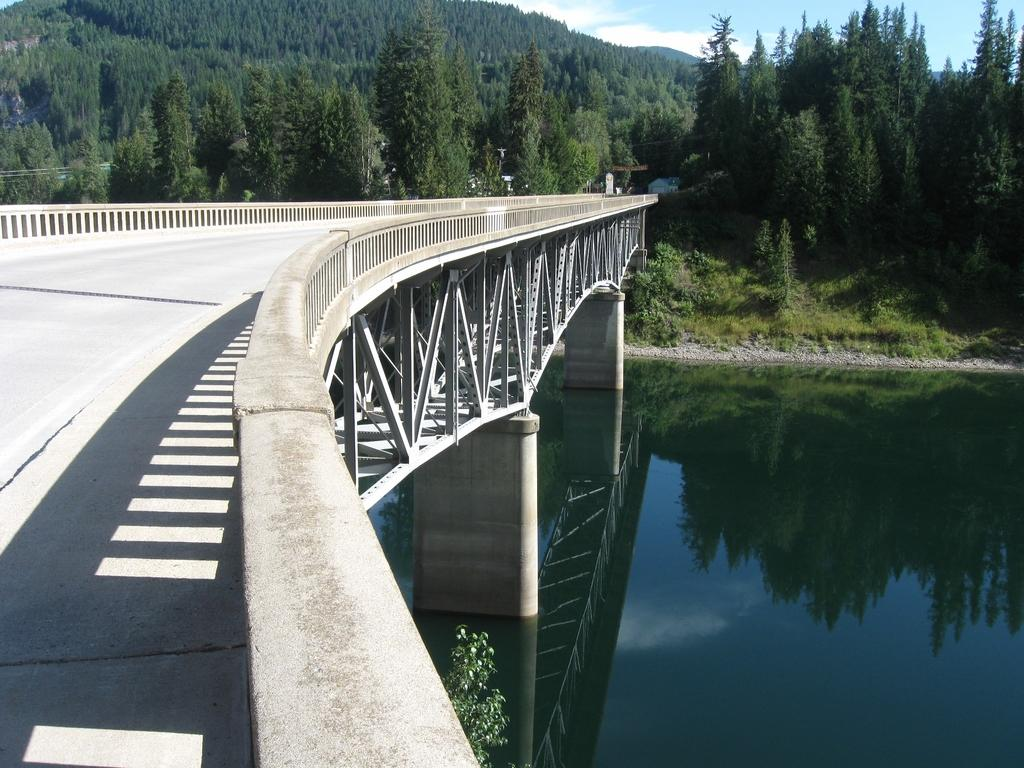What structure is the main subject of the image? There is a bridge in the image. What can be seen in the background of the image? The background of the image includes water and trees with green color. What is the color of the sky in the image? The sky is visible in the background, with blue and white colors. What type of lettuce is growing in the cellar in the image? There is no lettuce or cellar present in the image. 